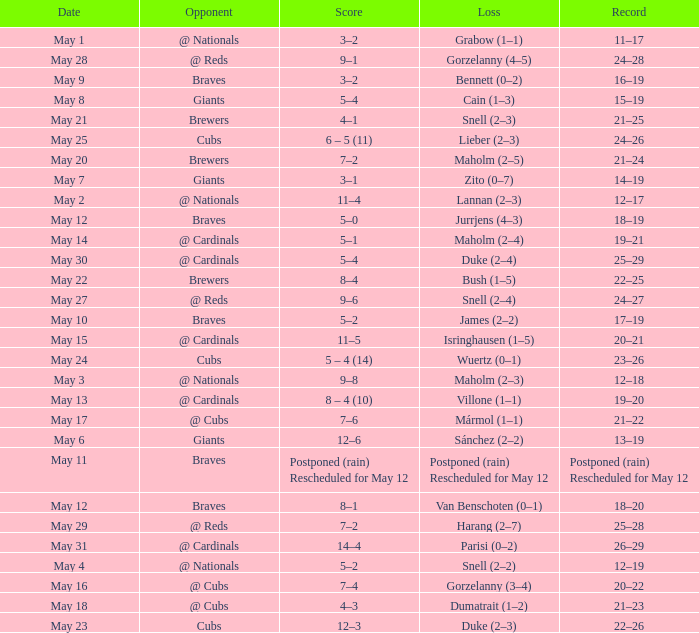What was the date of the game with a loss of Bush (1–5)? May 22. 